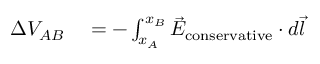<formula> <loc_0><loc_0><loc_500><loc_500>\begin{array} { r l } { \Delta V _ { A B } } & = - \int _ { x _ { A } } ^ { x _ { B } } { \vec { E } } _ { c o n s e r v a t i v e } \cdot d { \vec { l } } } \end{array}</formula> 